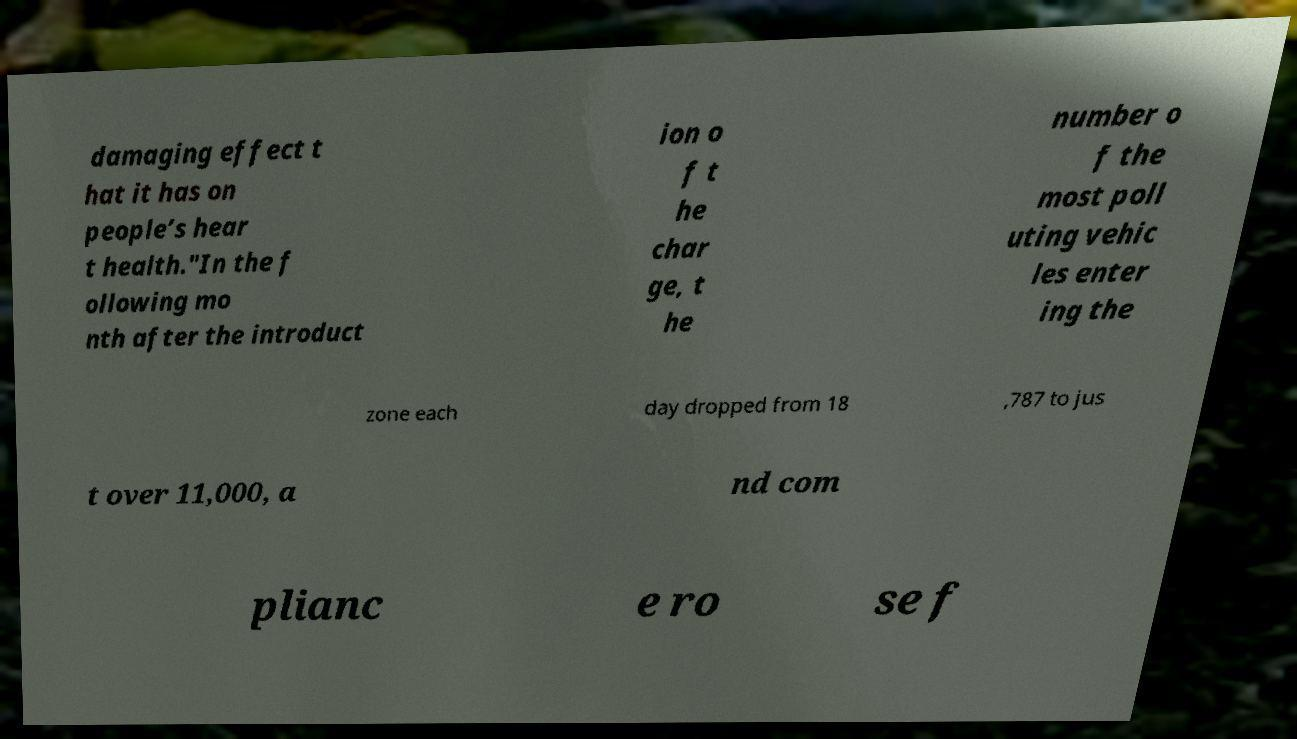For documentation purposes, I need the text within this image transcribed. Could you provide that? damaging effect t hat it has on people’s hear t health."In the f ollowing mo nth after the introduct ion o f t he char ge, t he number o f the most poll uting vehic les enter ing the zone each day dropped from 18 ,787 to jus t over 11,000, a nd com plianc e ro se f 